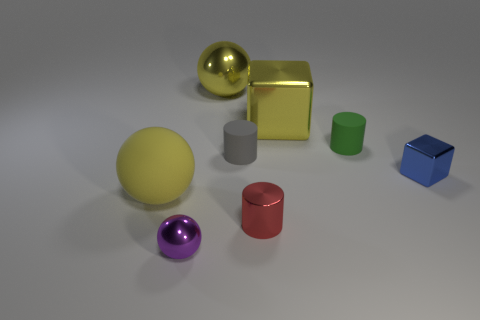Is there any other thing that is the same material as the red thing?
Make the answer very short. Yes. What is the shape of the small purple object?
Your answer should be compact. Sphere. Is the color of the large sphere that is on the right side of the matte sphere the same as the matte thing that is on the left side of the tiny purple sphere?
Offer a very short reply. Yes. Do the yellow matte thing and the red thing have the same shape?
Your response must be concise. No. Is there any other thing that has the same shape as the large matte thing?
Your answer should be compact. Yes. Do the large ball that is in front of the small gray rubber object and the green object have the same material?
Ensure brevity in your answer.  Yes. What is the shape of the small thing that is on the right side of the yellow metal cube and in front of the small gray matte cylinder?
Provide a succinct answer. Cube. Is there a tiny green matte cylinder in front of the yellow thing that is left of the big yellow shiny ball?
Ensure brevity in your answer.  No. How many other objects are the same material as the small red object?
Your response must be concise. 4. Does the green matte thing that is to the right of the gray rubber thing have the same shape as the large yellow thing to the left of the big metallic ball?
Your answer should be compact. No. 